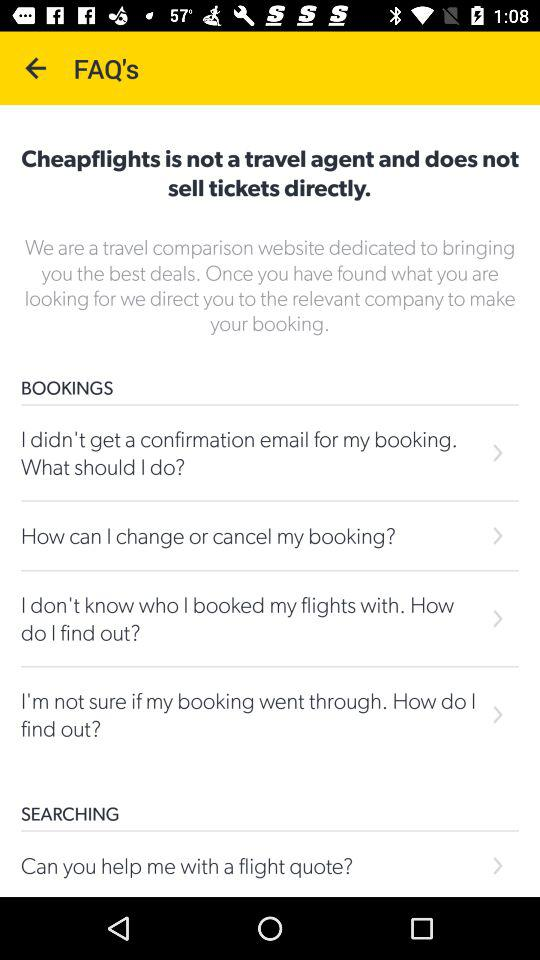How many FAQs are there about bookings?
Answer the question using a single word or phrase. 4 